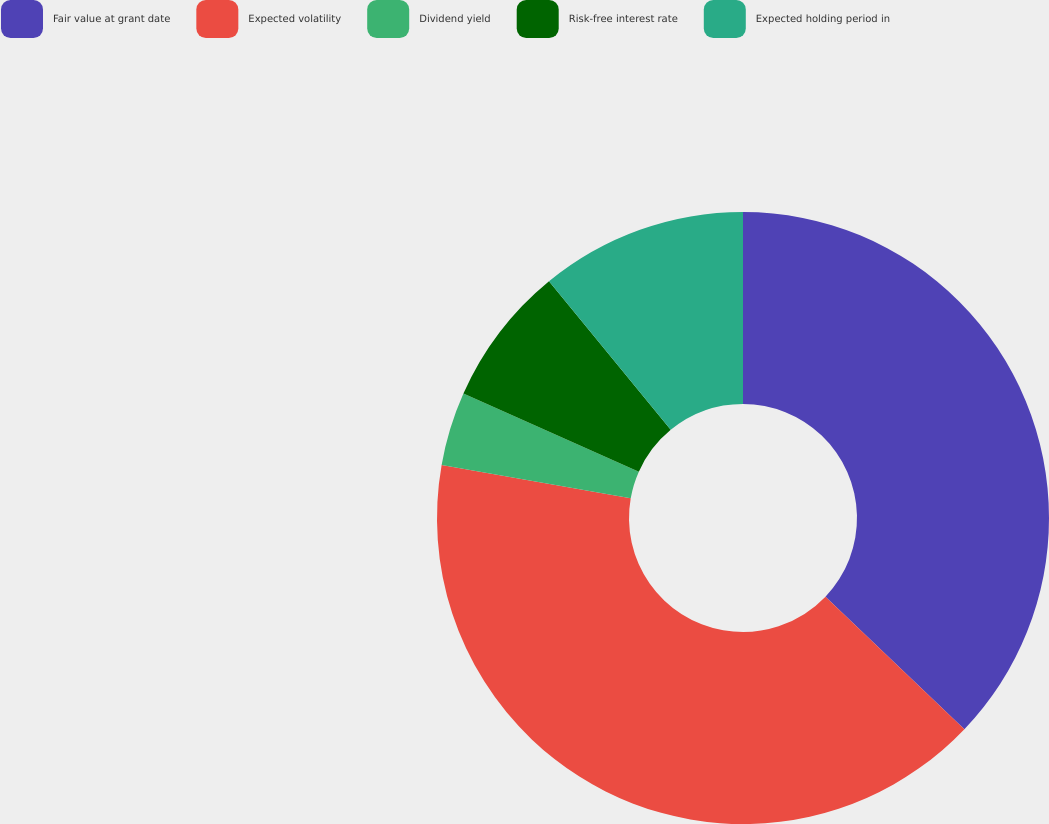Convert chart. <chart><loc_0><loc_0><loc_500><loc_500><pie_chart><fcel>Fair value at grant date<fcel>Expected volatility<fcel>Dividend yield<fcel>Risk-free interest rate<fcel>Expected holding period in<nl><fcel>37.13%<fcel>40.65%<fcel>3.89%<fcel>7.41%<fcel>10.93%<nl></chart> 